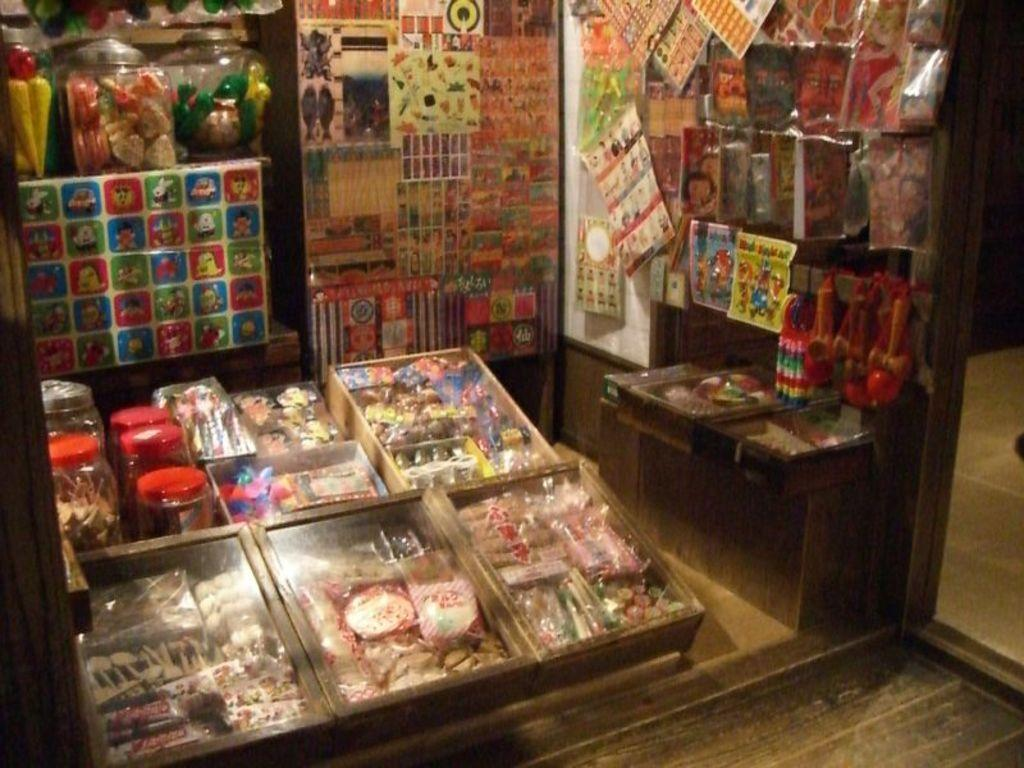What type of establishment is depicted in the image? The image is of a shop. What can be seen on the walls of the shop? There are posters in the shop. What type of containers are present in the shop? There are jars in the shop. What type of products are available in the shop? There are food items and playing things in the shop. What else can be found in the shop? There are other objects in the shop. What part of the shop's floor is visible in the image? The floor is visible on the right side of the image. What type of glove is being used by the achiever in the image? There is no achiever or glove present in the image; it is a shop with various items and objects. 